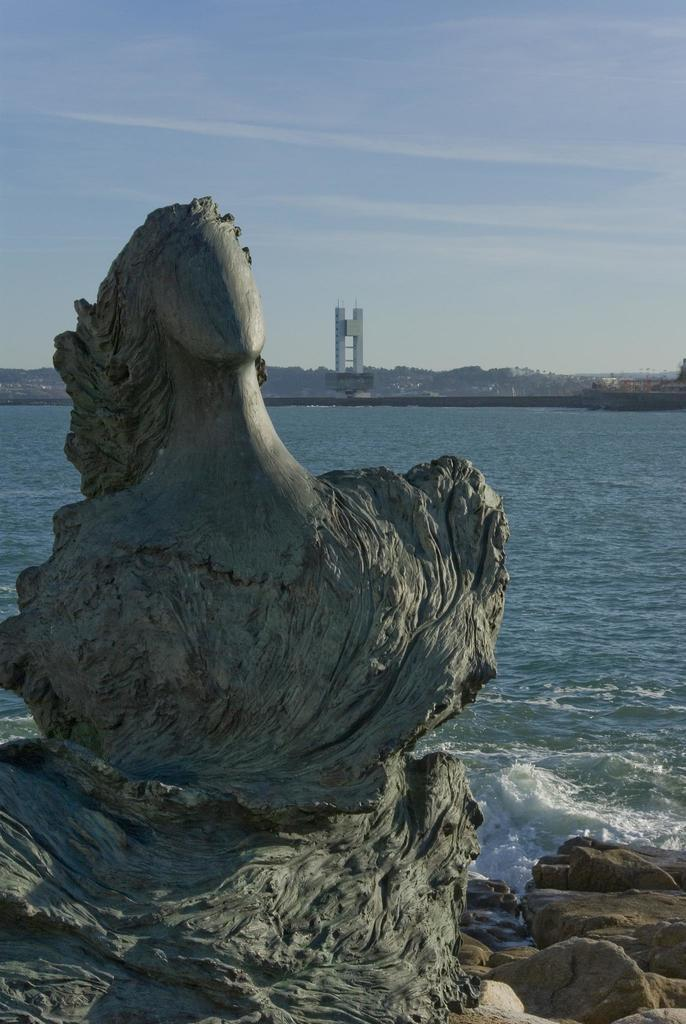What can be seen in the background of the image? In the background of the image, there is a sky, hills, a tower, and the sea. What is present on the stone in the image? There is carving on a stone in the image. What type of terrain is visible in the image? There are rocks in the image. How many hands are visible on the tower in the image? There are no hands visible on the tower in the image. What degree of difficulty is associated with the carving on the stone in the image? The facts provided do not mention any degree of difficulty associated with the carving on the stone in the image. 